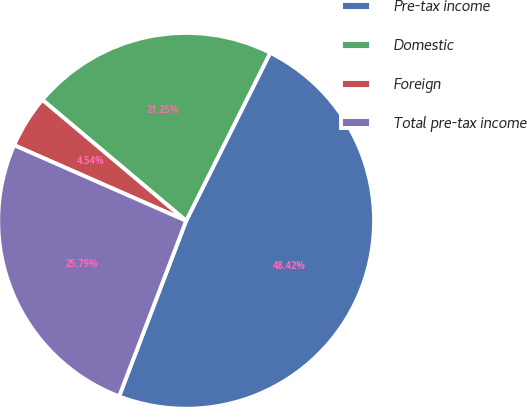Convert chart to OTSL. <chart><loc_0><loc_0><loc_500><loc_500><pie_chart><fcel>Pre-tax income<fcel>Domestic<fcel>Foreign<fcel>Total pre-tax income<nl><fcel>48.42%<fcel>21.25%<fcel>4.54%<fcel>25.79%<nl></chart> 